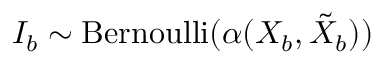<formula> <loc_0><loc_0><loc_500><loc_500>I _ { b } \sim B e r n o u l l i ( \alpha ( X _ { b } , \tilde { X } _ { b } ) )</formula> 